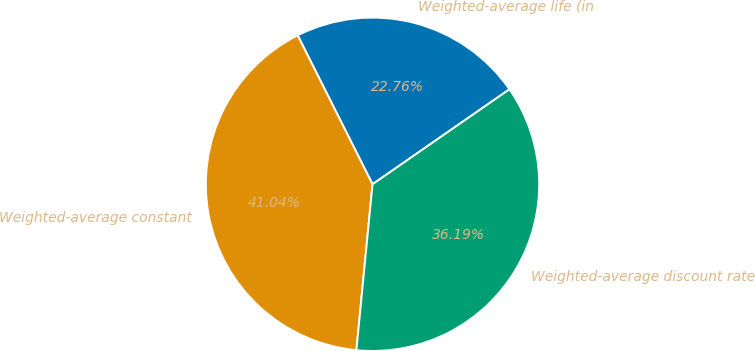Convert chart. <chart><loc_0><loc_0><loc_500><loc_500><pie_chart><fcel>Weighted-average life (in<fcel>Weighted-average constant<fcel>Weighted-average discount rate<nl><fcel>22.76%<fcel>41.04%<fcel>36.19%<nl></chart> 